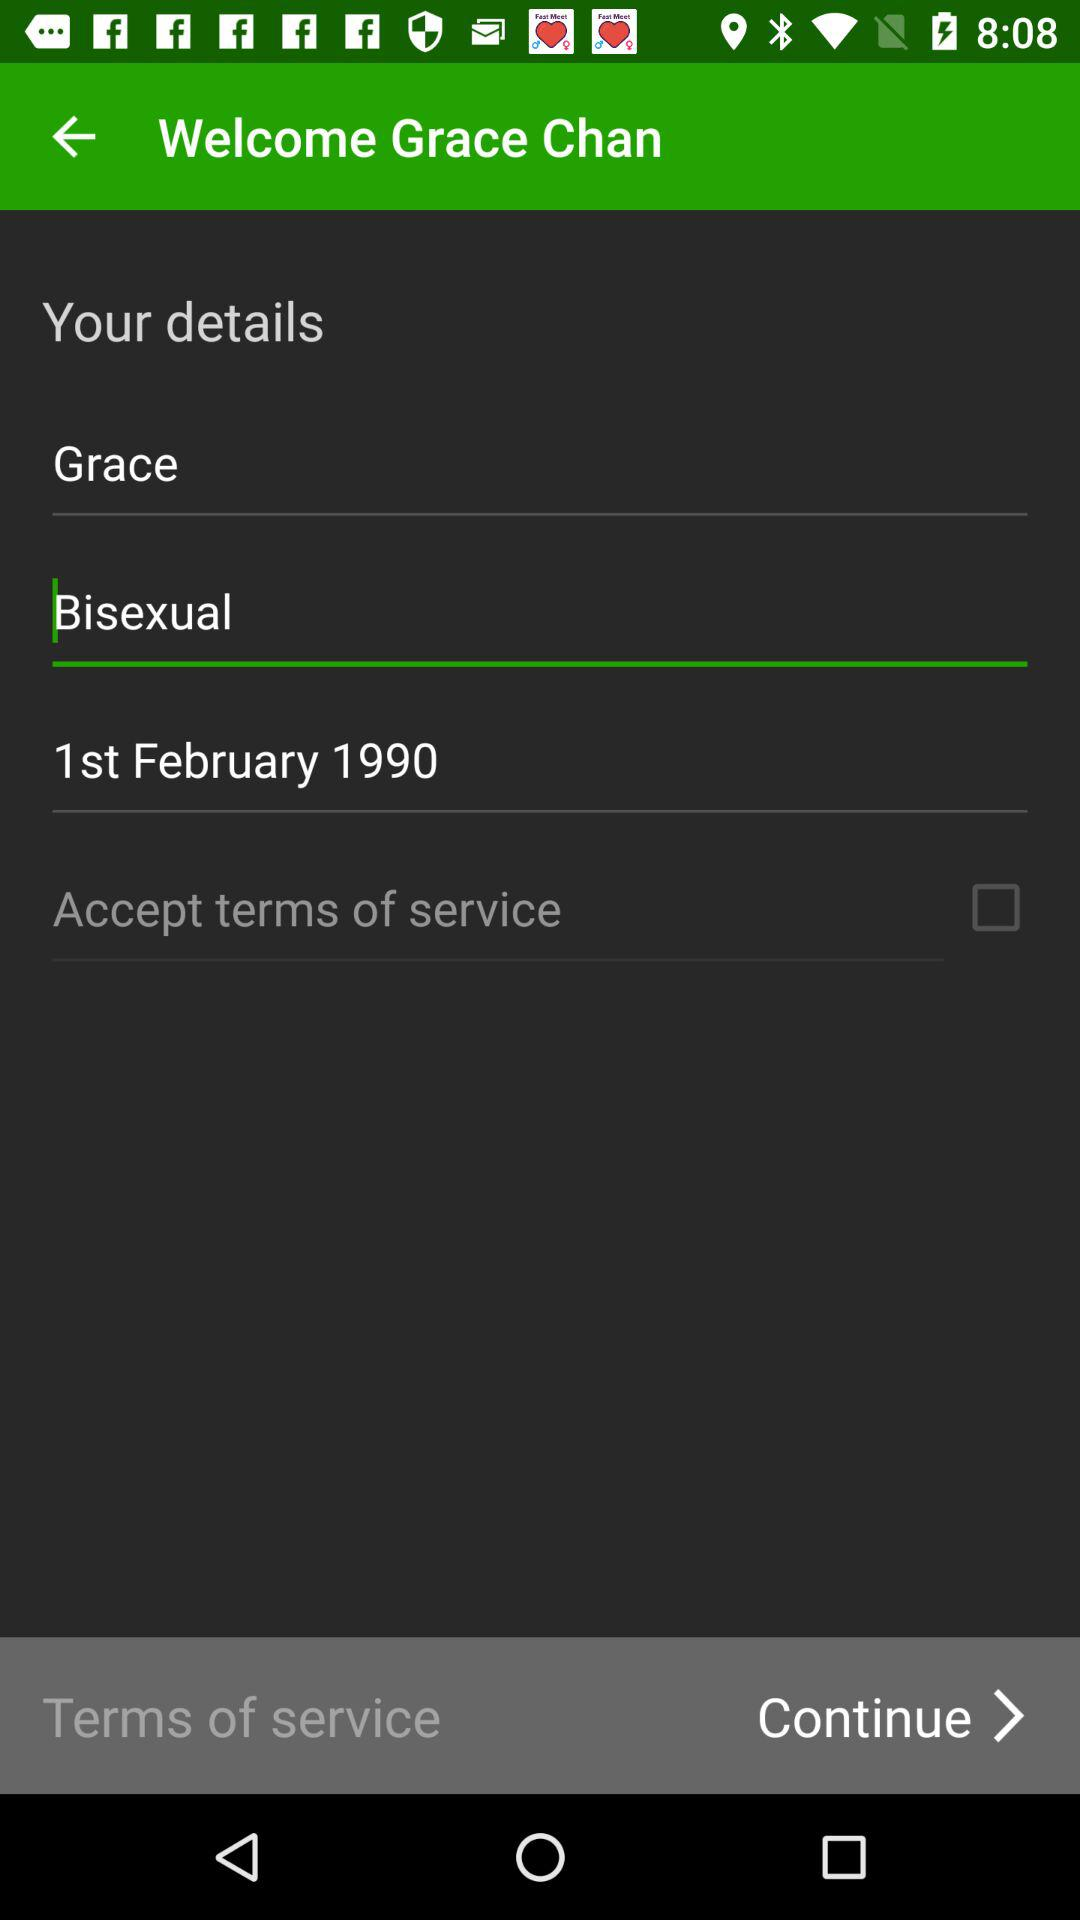What is the name? The name is Grace Chan. 